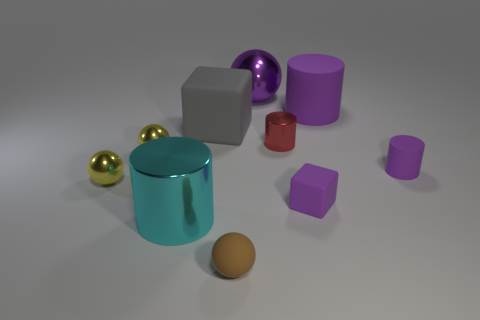Subtract all yellow cylinders. Subtract all brown cubes. How many cylinders are left? 4 Subtract all cubes. How many objects are left? 8 Subtract 0 gray cylinders. How many objects are left? 10 Subtract all gray metal cylinders. Subtract all big rubber cubes. How many objects are left? 9 Add 1 red metallic things. How many red metallic things are left? 2 Add 6 tiny brown spheres. How many tiny brown spheres exist? 7 